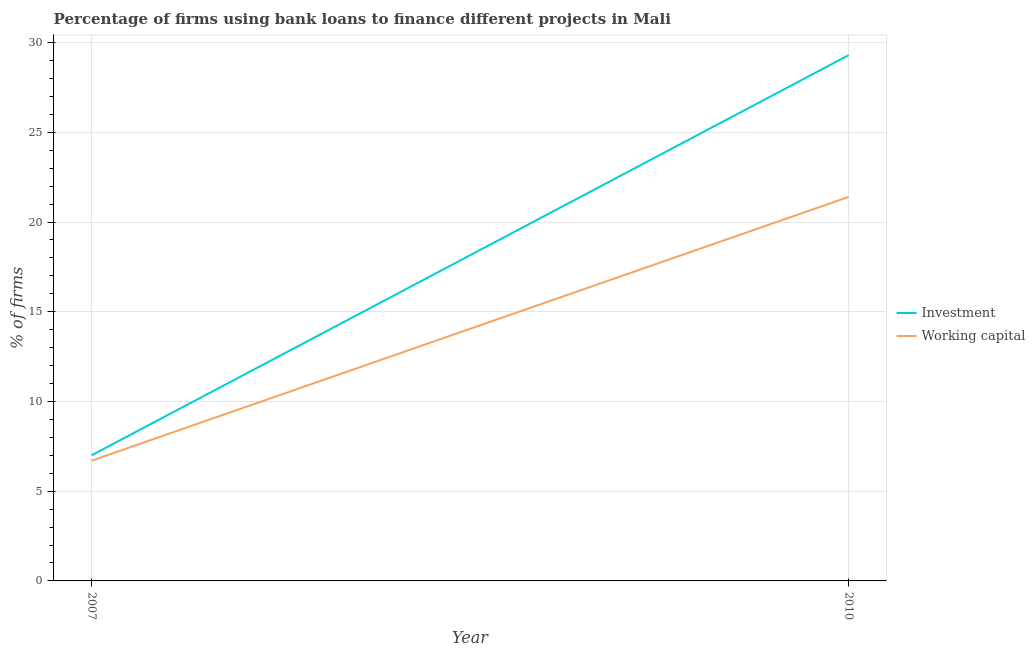Is the number of lines equal to the number of legend labels?
Give a very brief answer. Yes. What is the percentage of firms using banks to finance investment in 2010?
Your answer should be compact. 29.3. Across all years, what is the maximum percentage of firms using banks to finance working capital?
Provide a succinct answer. 21.4. What is the total percentage of firms using banks to finance working capital in the graph?
Provide a short and direct response. 28.1. What is the difference between the percentage of firms using banks to finance investment in 2007 and that in 2010?
Give a very brief answer. -22.3. What is the difference between the percentage of firms using banks to finance working capital in 2007 and the percentage of firms using banks to finance investment in 2010?
Provide a succinct answer. -22.6. What is the average percentage of firms using banks to finance working capital per year?
Make the answer very short. 14.05. In the year 2007, what is the difference between the percentage of firms using banks to finance investment and percentage of firms using banks to finance working capital?
Make the answer very short. 0.3. What is the ratio of the percentage of firms using banks to finance investment in 2007 to that in 2010?
Your answer should be very brief. 0.24. Is the percentage of firms using banks to finance investment in 2007 less than that in 2010?
Provide a succinct answer. Yes. Is the percentage of firms using banks to finance investment strictly greater than the percentage of firms using banks to finance working capital over the years?
Your answer should be very brief. Yes. How many lines are there?
Give a very brief answer. 2. What is the difference between two consecutive major ticks on the Y-axis?
Your response must be concise. 5. Are the values on the major ticks of Y-axis written in scientific E-notation?
Ensure brevity in your answer.  No. Does the graph contain any zero values?
Your answer should be compact. No. Where does the legend appear in the graph?
Give a very brief answer. Center right. How many legend labels are there?
Offer a very short reply. 2. How are the legend labels stacked?
Provide a short and direct response. Vertical. What is the title of the graph?
Provide a succinct answer. Percentage of firms using bank loans to finance different projects in Mali. Does "Age 65(male)" appear as one of the legend labels in the graph?
Your answer should be very brief. No. What is the label or title of the Y-axis?
Keep it short and to the point. % of firms. What is the % of firms of Investment in 2010?
Ensure brevity in your answer.  29.3. What is the % of firms in Working capital in 2010?
Provide a short and direct response. 21.4. Across all years, what is the maximum % of firms of Investment?
Your answer should be compact. 29.3. Across all years, what is the maximum % of firms of Working capital?
Provide a short and direct response. 21.4. Across all years, what is the minimum % of firms in Investment?
Your response must be concise. 7. What is the total % of firms in Investment in the graph?
Your response must be concise. 36.3. What is the total % of firms in Working capital in the graph?
Offer a terse response. 28.1. What is the difference between the % of firms in Investment in 2007 and that in 2010?
Offer a terse response. -22.3. What is the difference between the % of firms of Working capital in 2007 and that in 2010?
Make the answer very short. -14.7. What is the difference between the % of firms of Investment in 2007 and the % of firms of Working capital in 2010?
Your response must be concise. -14.4. What is the average % of firms in Investment per year?
Make the answer very short. 18.15. What is the average % of firms in Working capital per year?
Ensure brevity in your answer.  14.05. In the year 2010, what is the difference between the % of firms in Investment and % of firms in Working capital?
Give a very brief answer. 7.9. What is the ratio of the % of firms in Investment in 2007 to that in 2010?
Your answer should be very brief. 0.24. What is the ratio of the % of firms in Working capital in 2007 to that in 2010?
Your response must be concise. 0.31. What is the difference between the highest and the second highest % of firms of Investment?
Offer a terse response. 22.3. What is the difference between the highest and the second highest % of firms in Working capital?
Provide a short and direct response. 14.7. What is the difference between the highest and the lowest % of firms of Investment?
Make the answer very short. 22.3. 